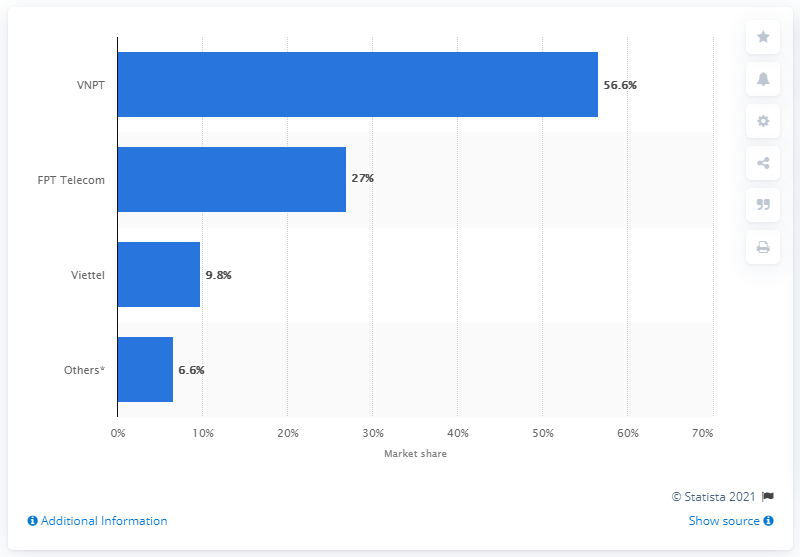Specify some key components in this picture. In the fourth quarter of 2013, the market share of the internet service provider in Vietnam was 56.6%. 